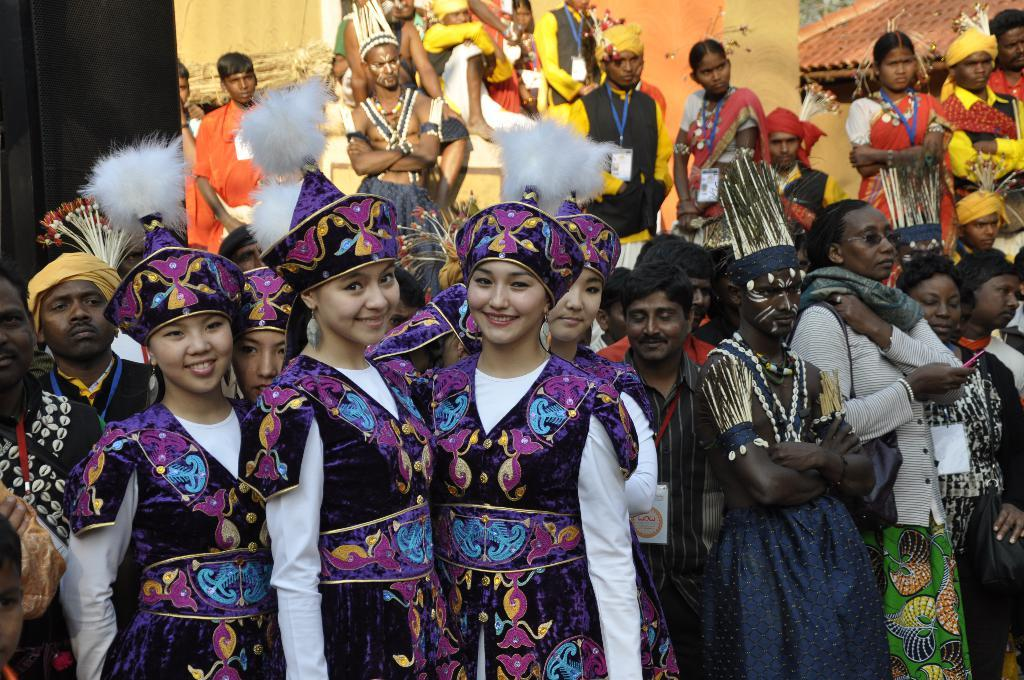Who is present in the image? There are people in the image. What are the people wearing? The people are dressed in cultural attire. What is the mood of the people in the image? The people are smiling, which suggests a positive mood. What type of key is being used to pop the balloon in the image? There is no key or balloon present in the image. What flavor of soda is being shared among the people in the image? There is no soda present in the image. 